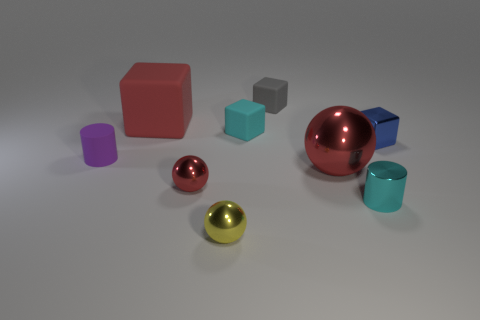How many other objects are there of the same shape as the tiny cyan rubber object?
Offer a terse response. 3. Is the number of small cyan things in front of the small red metal thing the same as the number of metal objects behind the red rubber cube?
Provide a short and direct response. No. What material is the tiny red ball?
Make the answer very short. Metal. What is the material of the small cyan thing that is behind the tiny purple thing?
Your answer should be compact. Rubber. Is there any other thing that has the same material as the cyan cube?
Ensure brevity in your answer.  Yes. Is the number of yellow shiny spheres in front of the purple object greater than the number of small red matte cylinders?
Provide a succinct answer. Yes. Is there a small cyan rubber cube that is to the left of the small cyan thing behind the cylinder on the right side of the large matte object?
Offer a terse response. No. There is a tiny shiny cube; are there any big red rubber objects left of it?
Your response must be concise. Yes. What number of large metal objects are the same color as the large matte cube?
Your response must be concise. 1. What is the size of the red cube that is made of the same material as the small gray cube?
Your answer should be compact. Large. 